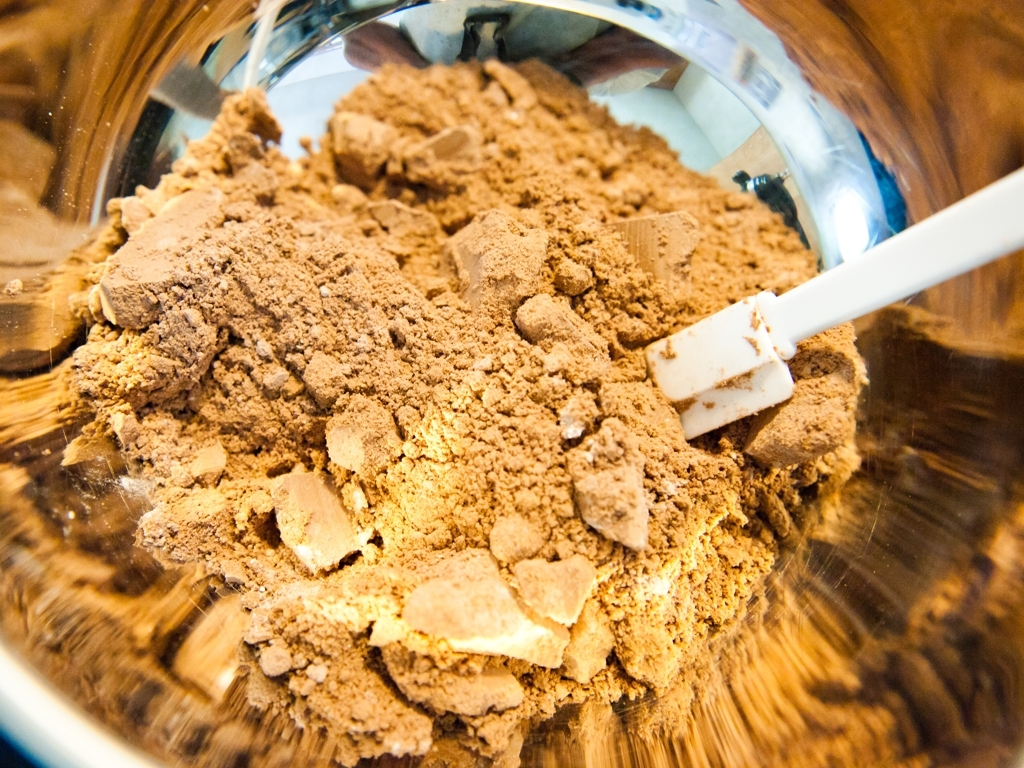Can you guess what this powder might be used for? Based on the texture and color, this powder could be used for cooking or baking, possibly as a spice or ingredient in recipes such as for making chocolates or desserts. 